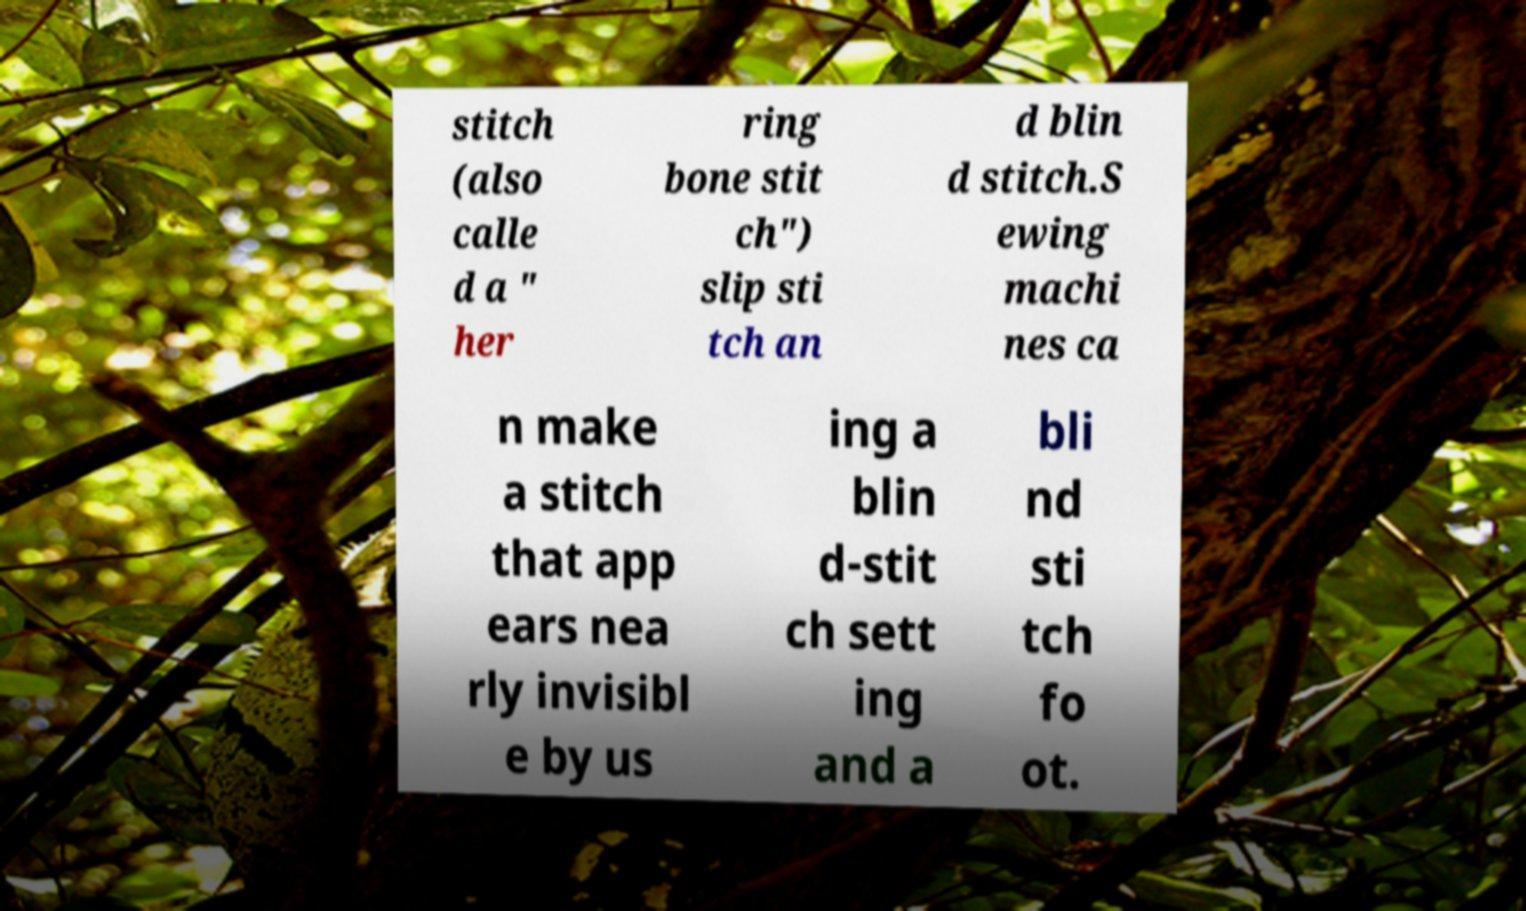Please identify and transcribe the text found in this image. stitch (also calle d a " her ring bone stit ch") slip sti tch an d blin d stitch.S ewing machi nes ca n make a stitch that app ears nea rly invisibl e by us ing a blin d-stit ch sett ing and a bli nd sti tch fo ot. 